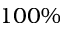Convert formula to latex. <formula><loc_0><loc_0><loc_500><loc_500>1 0 0 \%</formula> 